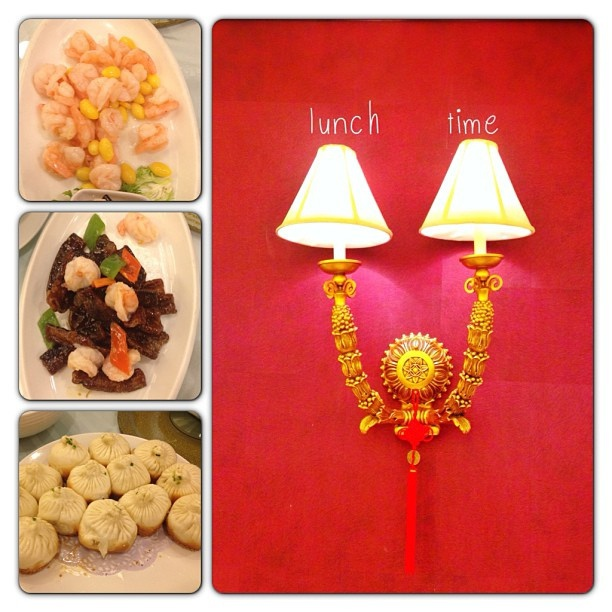Describe the objects in this image and their specific colors. I can see carrot in white, red, and brown tones and carrot in white, red, brown, and maroon tones in this image. 